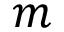<formula> <loc_0><loc_0><loc_500><loc_500>m</formula> 